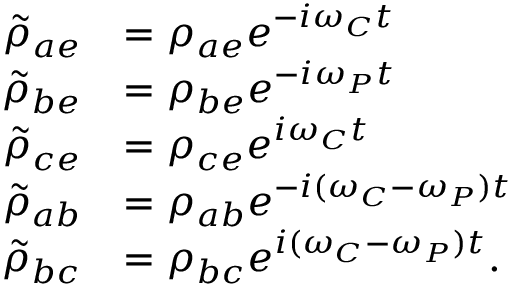Convert formula to latex. <formula><loc_0><loc_0><loc_500><loc_500>\begin{array} { r l } { \tilde { \rho } _ { a e } } & { = \rho _ { a e } e ^ { - i \omega _ { C } t } } \\ { \tilde { \rho } _ { b e } } & { = \rho _ { b e } e ^ { - i \omega _ { P } t } } \\ { \tilde { \rho } _ { c e } } & { = \rho _ { c e } e ^ { i \omega _ { C } t } } \\ { \tilde { \rho } _ { a b } } & { = \rho _ { a b } e ^ { - i ( \omega _ { C } - \omega _ { P } ) t } } \\ { \tilde { \rho } _ { b c } } & { = \rho _ { b c } e ^ { i ( \omega _ { C } - \omega _ { P } ) t } . } \end{array}</formula> 